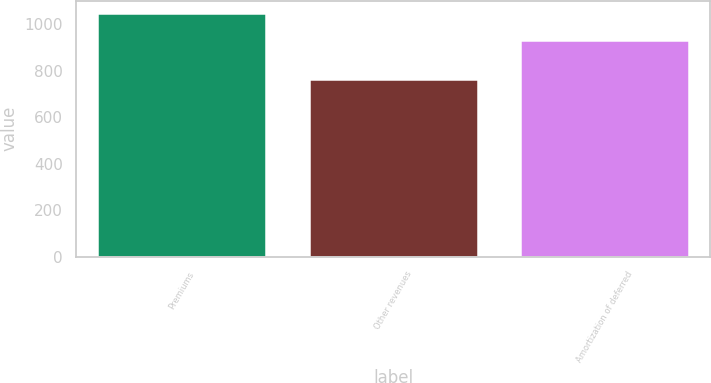Convert chart to OTSL. <chart><loc_0><loc_0><loc_500><loc_500><bar_chart><fcel>Premiums<fcel>Other revenues<fcel>Amortization of deferred<nl><fcel>1048<fcel>766<fcel>933<nl></chart> 